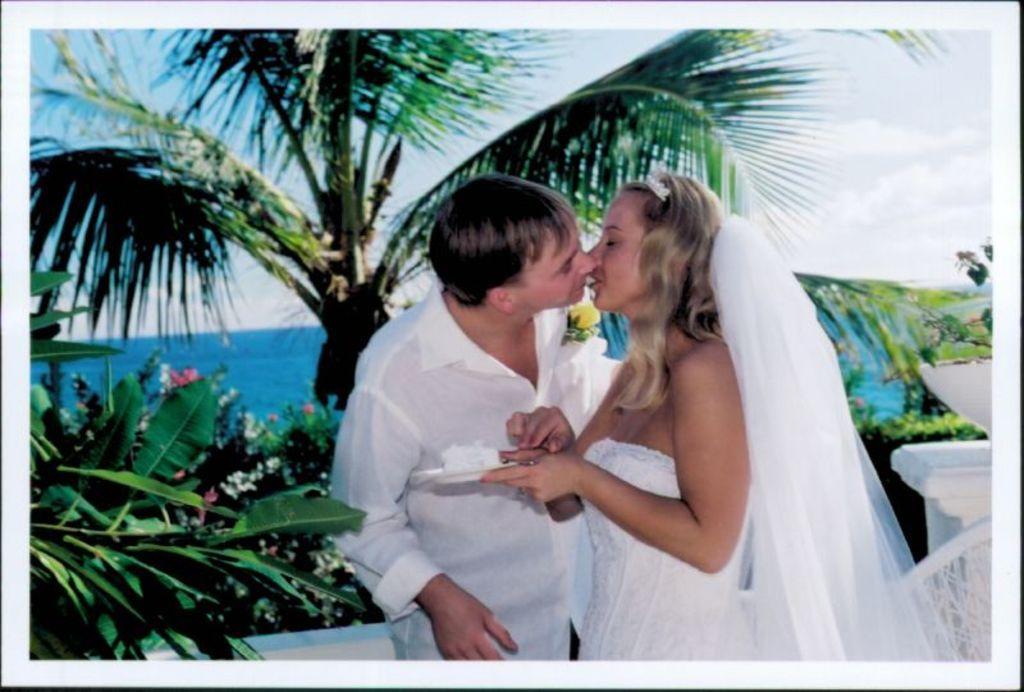Could you give a brief overview of what you see in this image? In this image there is a couple kissing, behind the couple there are trees and water. 